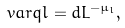Convert formula to latex. <formula><loc_0><loc_0><loc_500><loc_500>\ v a r q l = d L ^ { - \mu _ { l } } ,</formula> 